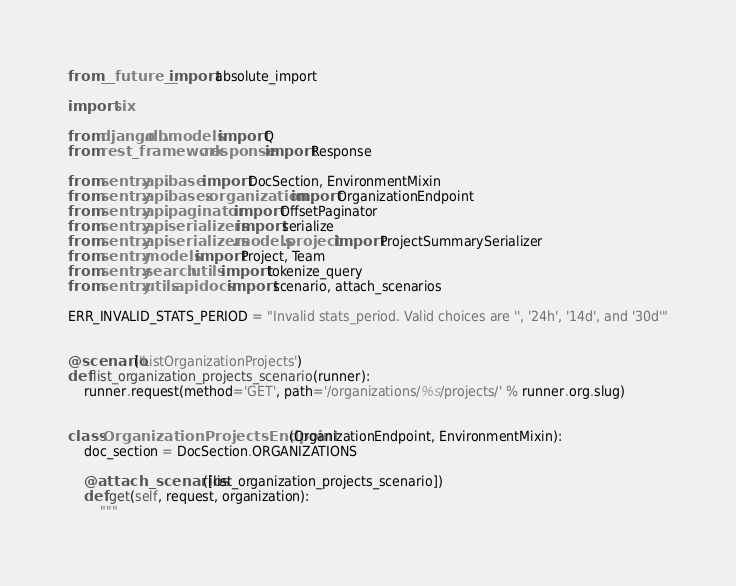Convert code to text. <code><loc_0><loc_0><loc_500><loc_500><_Python_>from __future__ import absolute_import

import six

from django.db.models import Q
from rest_framework.response import Response

from sentry.api.base import DocSection, EnvironmentMixin
from sentry.api.bases.organization import OrganizationEndpoint
from sentry.api.paginator import OffsetPaginator
from sentry.api.serializers import serialize
from sentry.api.serializers.models.project import ProjectSummarySerializer
from sentry.models import Project, Team
from sentry.search.utils import tokenize_query
from sentry.utils.apidocs import scenario, attach_scenarios

ERR_INVALID_STATS_PERIOD = "Invalid stats_period. Valid choices are '', '24h', '14d', and '30d'"


@scenario('ListOrganizationProjects')
def list_organization_projects_scenario(runner):
    runner.request(method='GET', path='/organizations/%s/projects/' % runner.org.slug)


class OrganizationProjectsEndpoint(OrganizationEndpoint, EnvironmentMixin):
    doc_section = DocSection.ORGANIZATIONS

    @attach_scenarios([list_organization_projects_scenario])
    def get(self, request, organization):
        """</code> 